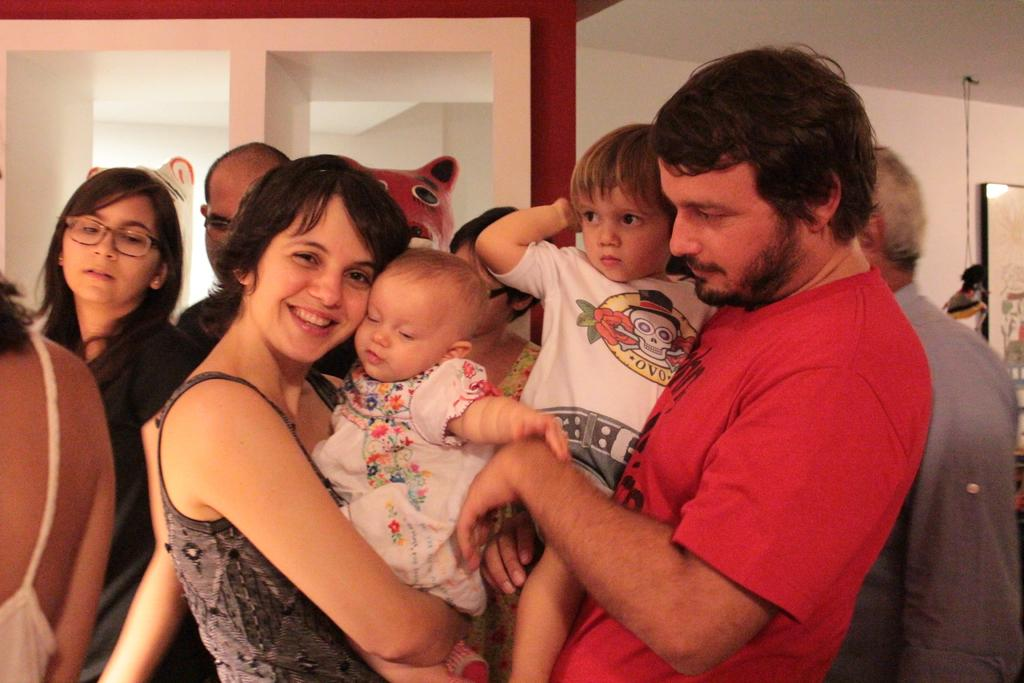Who are the people in the image? There is a man and a woman in the image. What is the woman doing in the image? The woman is holding a child and smiling. Can you describe the people standing near a wall in the background of the image? There are people standing near a wall in the background of the image, but their specific actions or features are not mentioned in the provided facts. What team do the people in the image belong to? There is no mention of a team in the provided facts. --- Facts: 1. There is a car in the image. 2. The car is red. 3. The car has four doors. 4. The car has a sunroof. 5. The car is parked on a street. Absurd Topics: parrot, piano, park Conversation: What type of vehicle is in the image? There is a car in the image. What color is the car? The car is red. How many doors does the car have? The car has four doors. Does the car have any special features? Yes, the car has a sunroof. Where is the car located in the image? The car is parked on a street. Reasoning: Let's think step by step in order to ${produce the conversation}. We start by identifying the main subject of the image, which is the car. Next, we describe specific features of the car, such as the color, the number of doors, and the presence of a sunroof. Then, we observe the location of the car in the image, which is parked on a street. Absurd Question/Answer: Can you hear the parrot playing the piano in the image? There is no mention of a parrot or a piano in the provided facts. --- Facts: 1. There is a group of people in the image. 2. The people are wearing matching t-shirts. 3. The t-shirts have the text "Friends Forever" printed on them. 4. The people are standing in a park. Absurd Topics: elephant, elephant ride, elephant trunk Conversation: How many people are in the image? There is a group of people in the image. What are the people wearing in the image? The people are wearing matching t-shirts. What is printed on the t-shirts? The t-shirts have the text "Friends Forever" printed on them. Where are the people located in the image? The people are standing in a park. Reasoning: Let's think step by step in order to ${produce the conversation}. We start by identifying the main subject of the image, which is the group of people. Next, we describe specific features of the people, such as the matching t-shirts they 